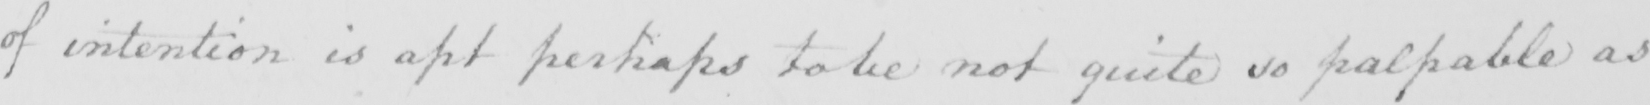Can you read and transcribe this handwriting? of intention is apt perhaps to be not quite so palpable as 